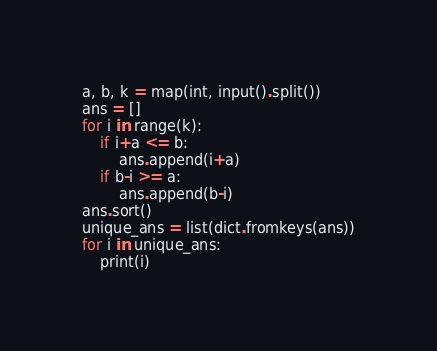<code> <loc_0><loc_0><loc_500><loc_500><_Python_>a, b, k = map(int, input().split())
ans = []
for i in range(k):
    if i+a <= b:
        ans.append(i+a)
    if b-i >= a:
        ans.append(b-i)
ans.sort()
unique_ans = list(dict.fromkeys(ans))
for i in unique_ans:
    print(i)</code> 